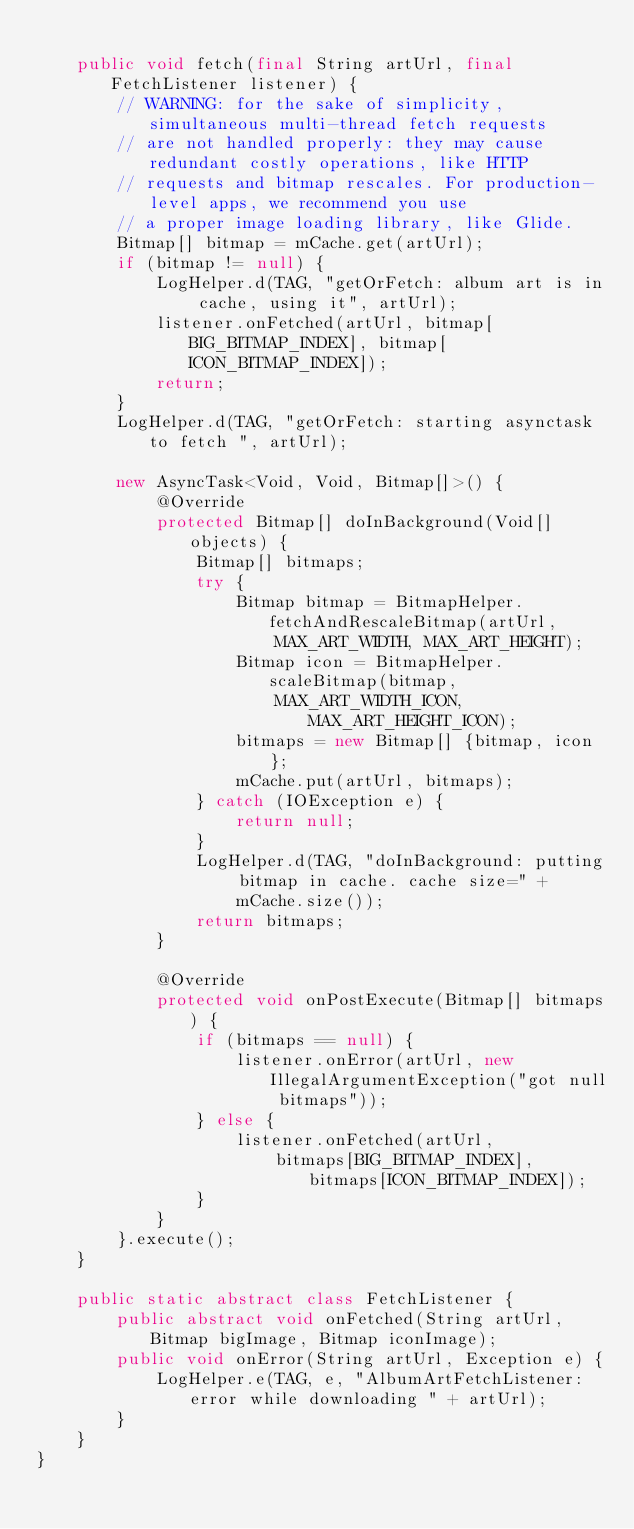Convert code to text. <code><loc_0><loc_0><loc_500><loc_500><_Java_>
    public void fetch(final String artUrl, final FetchListener listener) {
        // WARNING: for the sake of simplicity, simultaneous multi-thread fetch requests
        // are not handled properly: they may cause redundant costly operations, like HTTP
        // requests and bitmap rescales. For production-level apps, we recommend you use
        // a proper image loading library, like Glide.
        Bitmap[] bitmap = mCache.get(artUrl);
        if (bitmap != null) {
            LogHelper.d(TAG, "getOrFetch: album art is in cache, using it", artUrl);
            listener.onFetched(artUrl, bitmap[BIG_BITMAP_INDEX], bitmap[ICON_BITMAP_INDEX]);
            return;
        }
        LogHelper.d(TAG, "getOrFetch: starting asynctask to fetch ", artUrl);

        new AsyncTask<Void, Void, Bitmap[]>() {
            @Override
            protected Bitmap[] doInBackground(Void[] objects) {
                Bitmap[] bitmaps;
                try {
                    Bitmap bitmap = BitmapHelper.fetchAndRescaleBitmap(artUrl,
                        MAX_ART_WIDTH, MAX_ART_HEIGHT);
                    Bitmap icon = BitmapHelper.scaleBitmap(bitmap,
                        MAX_ART_WIDTH_ICON, MAX_ART_HEIGHT_ICON);
                    bitmaps = new Bitmap[] {bitmap, icon};
                    mCache.put(artUrl, bitmaps);
                } catch (IOException e) {
                    return null;
                }
                LogHelper.d(TAG, "doInBackground: putting bitmap in cache. cache size=" +
                    mCache.size());
                return bitmaps;
            }

            @Override
            protected void onPostExecute(Bitmap[] bitmaps) {
                if (bitmaps == null) {
                    listener.onError(artUrl, new IllegalArgumentException("got null bitmaps"));
                } else {
                    listener.onFetched(artUrl,
                        bitmaps[BIG_BITMAP_INDEX], bitmaps[ICON_BITMAP_INDEX]);
                }
            }
        }.execute();
    }

    public static abstract class FetchListener {
        public abstract void onFetched(String artUrl, Bitmap bigImage, Bitmap iconImage);
        public void onError(String artUrl, Exception e) {
            LogHelper.e(TAG, e, "AlbumArtFetchListener: error while downloading " + artUrl);
        }
    }
}
</code> 